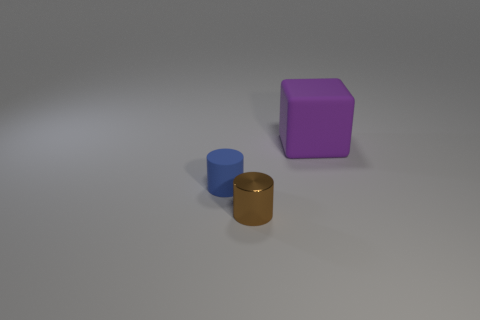Can you estimate the relative sizes of the objects in the image? Certainly, based on their proportions relative to each other, the purple object appears to be the largest, followed by the golden brown cylinder, and then the blue object, which is the smallest. 